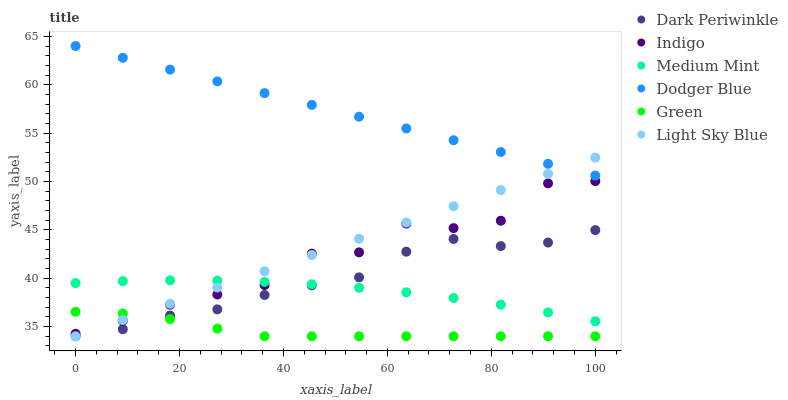Does Green have the minimum area under the curve?
Answer yes or no. Yes. Does Dodger Blue have the maximum area under the curve?
Answer yes or no. Yes. Does Indigo have the minimum area under the curve?
Answer yes or no. No. Does Indigo have the maximum area under the curve?
Answer yes or no. No. Is Light Sky Blue the smoothest?
Answer yes or no. Yes. Is Indigo the roughest?
Answer yes or no. Yes. Is Indigo the smoothest?
Answer yes or no. No. Is Light Sky Blue the roughest?
Answer yes or no. No. Does Light Sky Blue have the lowest value?
Answer yes or no. Yes. Does Indigo have the lowest value?
Answer yes or no. No. Does Dodger Blue have the highest value?
Answer yes or no. Yes. Does Indigo have the highest value?
Answer yes or no. No. Is Dark Periwinkle less than Dodger Blue?
Answer yes or no. Yes. Is Dodger Blue greater than Indigo?
Answer yes or no. Yes. Does Dark Periwinkle intersect Light Sky Blue?
Answer yes or no. Yes. Is Dark Periwinkle less than Light Sky Blue?
Answer yes or no. No. Is Dark Periwinkle greater than Light Sky Blue?
Answer yes or no. No. Does Dark Periwinkle intersect Dodger Blue?
Answer yes or no. No. 